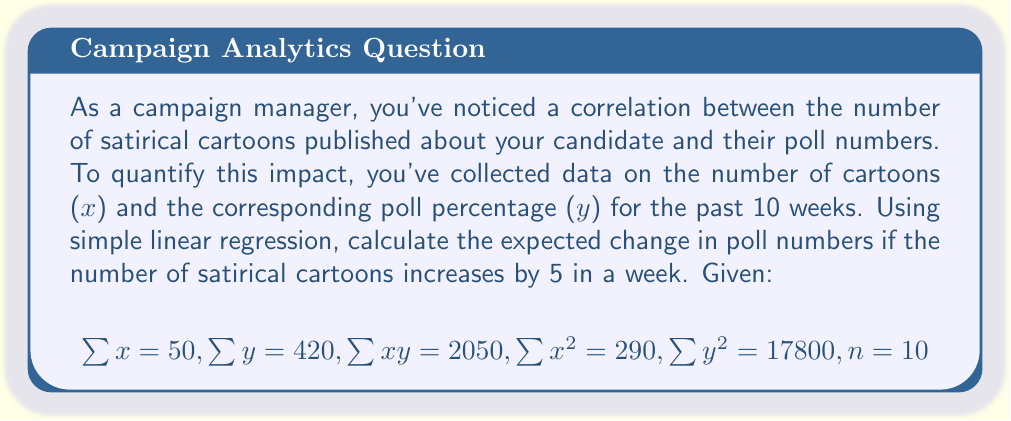Help me with this question. To solve this problem, we'll use simple linear regression to find the relationship between the number of cartoons (x) and poll numbers (y). Then, we'll use the slope of the regression line to predict the change in poll numbers.

1. Calculate the slope (b) of the regression line:
   $$b = \frac{n\sum xy - \sum x \sum y}{n\sum x^2 - (\sum x)^2}$$

2. Substitute the given values:
   $$b = \frac{10(2050) - 50(420)}{10(290) - 50^2}$$
   $$b = \frac{20500 - 21000}{2900 - 2500}$$
   $$b = \frac{-500}{400} = -1.25$$

3. The slope indicates that for each additional cartoon, the poll numbers decrease by 1.25 percentage points.

4. To find the change in poll numbers for an increase of 5 cartoons, multiply the slope by 5:
   $$\text{Change in poll numbers} = 5 \times (-1.25) = -6.25$$
Answer: The expected change in poll numbers if the number of satirical cartoons increases by 5 in a week is a decrease of 6.25 percentage points. 